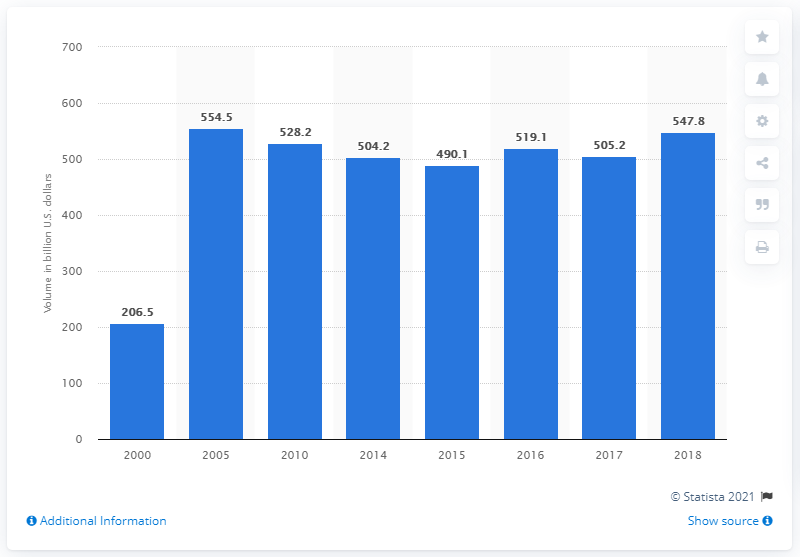Point out several critical features in this image. In 2018, the average amount of U.S. government securities bought and sold was 547.8. In 2018, the average amount of treasury securities traded per day was 547.8. 